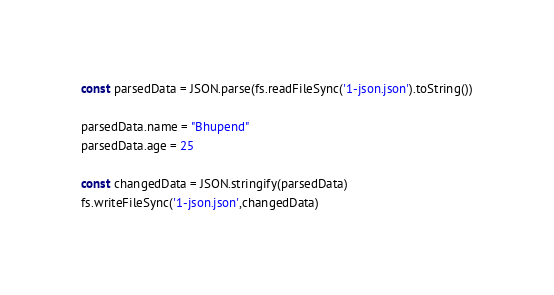<code> <loc_0><loc_0><loc_500><loc_500><_JavaScript_>
const parsedData = JSON.parse(fs.readFileSync('1-json.json').toString())

parsedData.name = "Bhupend"
parsedData.age = 25

const changedData = JSON.stringify(parsedData)
fs.writeFileSync('1-json.json',changedData)</code> 